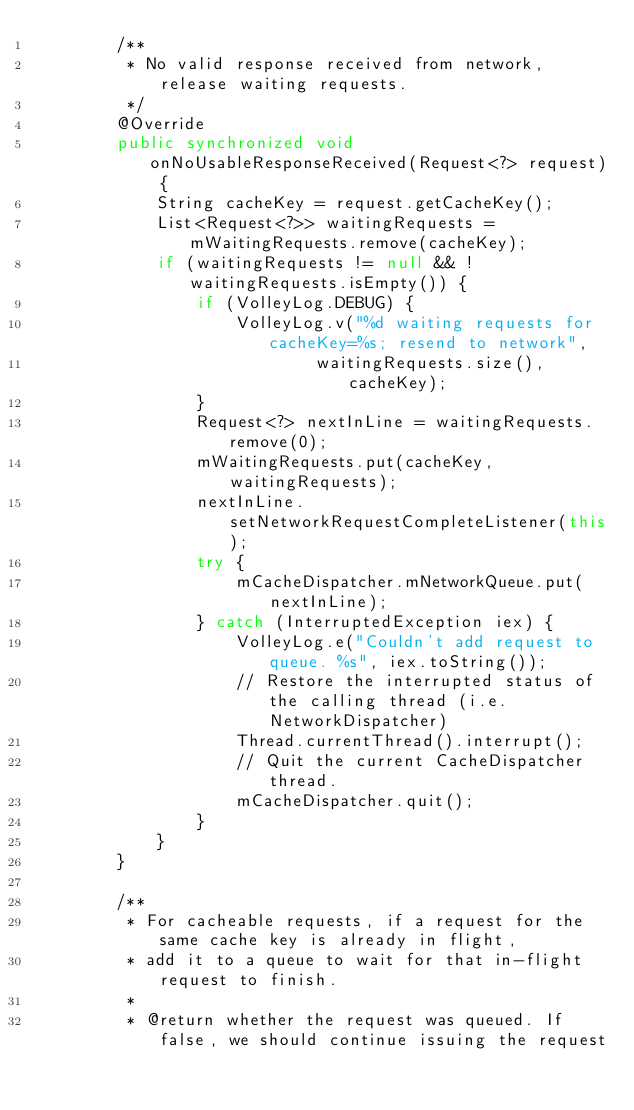Convert code to text. <code><loc_0><loc_0><loc_500><loc_500><_Java_>        /**
         * No valid response received from network, release waiting requests.
         */
        @Override
        public synchronized void onNoUsableResponseReceived(Request<?> request) {
            String cacheKey = request.getCacheKey();
            List<Request<?>> waitingRequests = mWaitingRequests.remove(cacheKey);
            if (waitingRequests != null && !waitingRequests.isEmpty()) {
                if (VolleyLog.DEBUG) {
                    VolleyLog.v("%d waiting requests for cacheKey=%s; resend to network",
                            waitingRequests.size(), cacheKey);
                }
                Request<?> nextInLine = waitingRequests.remove(0);
                mWaitingRequests.put(cacheKey, waitingRequests);
                nextInLine.setNetworkRequestCompleteListener(this);
                try {
                    mCacheDispatcher.mNetworkQueue.put(nextInLine);
                } catch (InterruptedException iex) {
                    VolleyLog.e("Couldn't add request to queue. %s", iex.toString());
                    // Restore the interrupted status of the calling thread (i.e. NetworkDispatcher)
                    Thread.currentThread().interrupt();
                    // Quit the current CacheDispatcher thread.
                    mCacheDispatcher.quit();
                }
            }
        }

        /**
         * For cacheable requests, if a request for the same cache key is already in flight,
         * add it to a queue to wait for that in-flight request to finish.
         *
         * @return whether the request was queued. If false, we should continue issuing the request</code> 